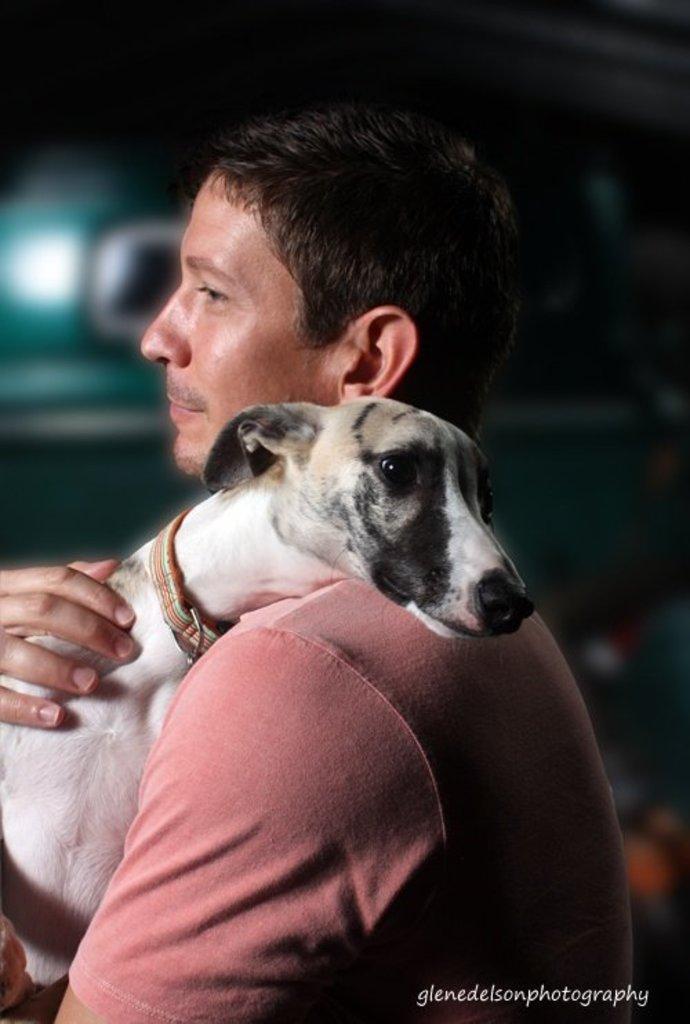Could you give a brief overview of what you see in this image? Here is a man who is wearing peach color shirt, he is holding dog in his arms,there is band around dog's neck and the dog is of white color. 